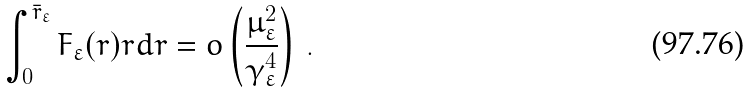Convert formula to latex. <formula><loc_0><loc_0><loc_500><loc_500>\int _ { 0 } ^ { \bar { r } _ { \varepsilon } } F _ { \varepsilon } ( r ) r d r = o \left ( \frac { \mu _ { \varepsilon } ^ { 2 } } { \gamma _ { \varepsilon } ^ { 4 } } \right ) \, .</formula> 